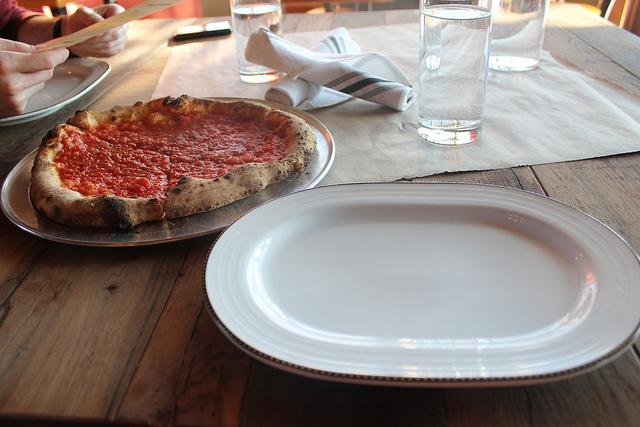Why is the plate empty? Please explain your reasoning. for customer. The plate is for the customer. 